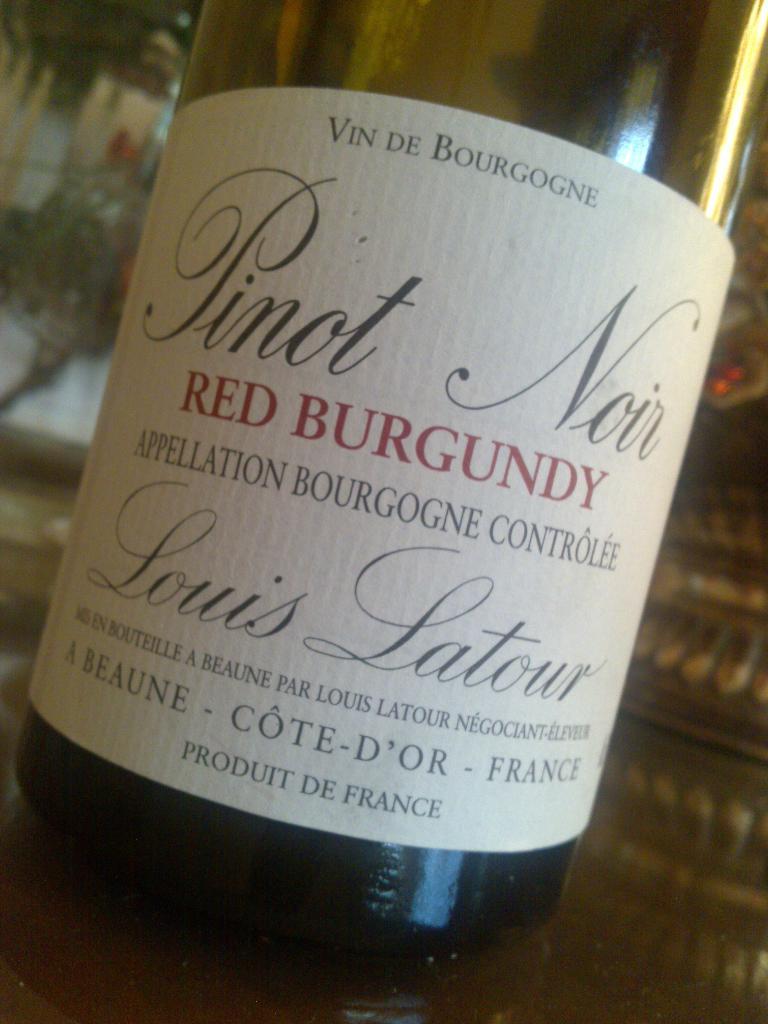In what country was this bottled?
Ensure brevity in your answer.  France. 